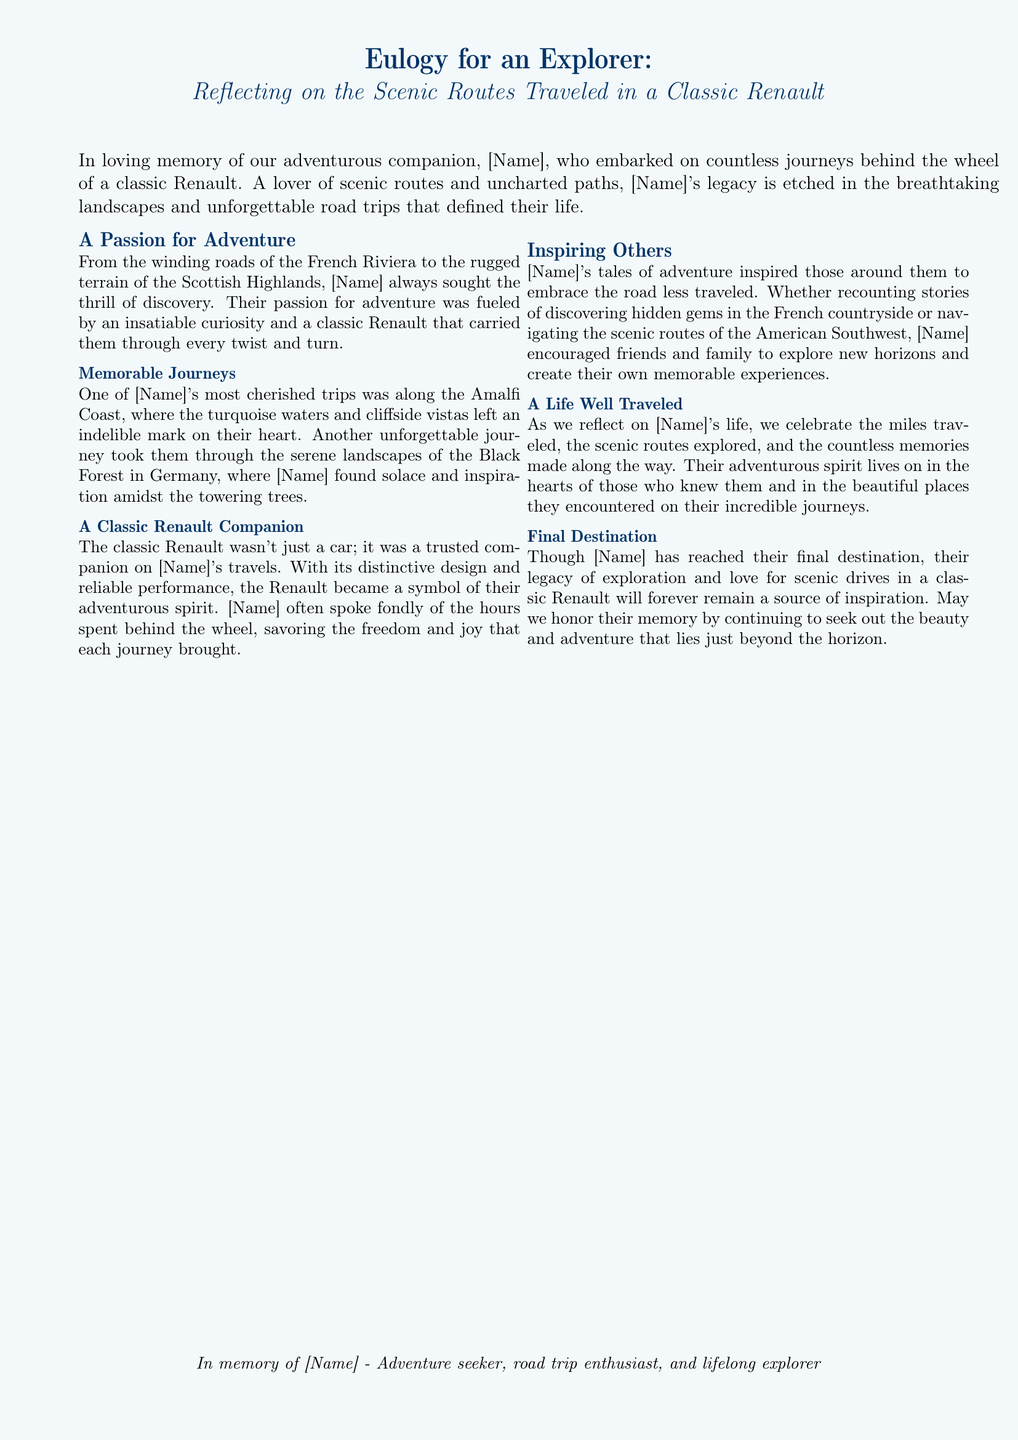What is the name of the person honored in the eulogy? The document placeholders indicate that the name is represented as [Name], which should be filled in.
Answer: [Name] What car model did [Name] travel in? The document mentions that [Name] traveled in a "classic Renault."
Answer: classic Renault Which scenic route is mentioned as one of [Name]'s cherished trips? The eulogy specifically highlights the Amalfi Coast as a memorable journey for [Name].
Answer: Amalfi Coast What type of vehicle is the classic Renault described as? The document describes the classic Renault as a "trusted companion" to [Name] during their travels.
Answer: trusted companion In what location did [Name] find solace and inspiration? The eulogy states that [Name] found solace and inspiration in the "Black Forest in Germany."
Answer: Black Forest in Germany What spirit does [Name] encourage in others? [Name]'s tales inspired those around them to "embrace the road less traveled."
Answer: road less traveled What is celebrated as we reflect on [Name]'s life? The document highlights that "the miles traveled" and memories made are celebrated in reflection of [Name]'s life.
Answer: miles traveled What does the eulogy say about [Name]'s legacy? The eulogy states that [Name]'s legacy of exploration remains a source of inspiration.
Answer: source of inspiration What is mentioned as [Name]'s final destination? The document refers to [Name]'s final destination without specifying, implying a metaphorical end to their journeys.
Answer: final destination 